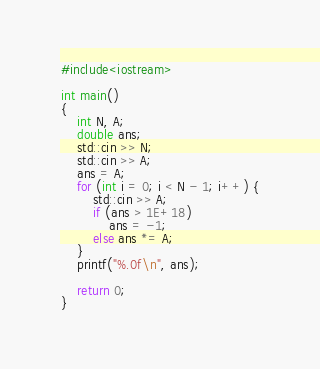<code> <loc_0><loc_0><loc_500><loc_500><_C++_>#include<iostream>

int main()
{
	int N, A;
	double ans;
	std::cin >> N;
	std::cin >> A;
	ans = A;
	for (int i = 0; i < N - 1; i++) {
		std::cin >> A;
		if (ans > 1E+18)
			ans = -1;
		else ans *= A;
	}
	printf("%.0f\n", ans);

	return 0;
}</code> 